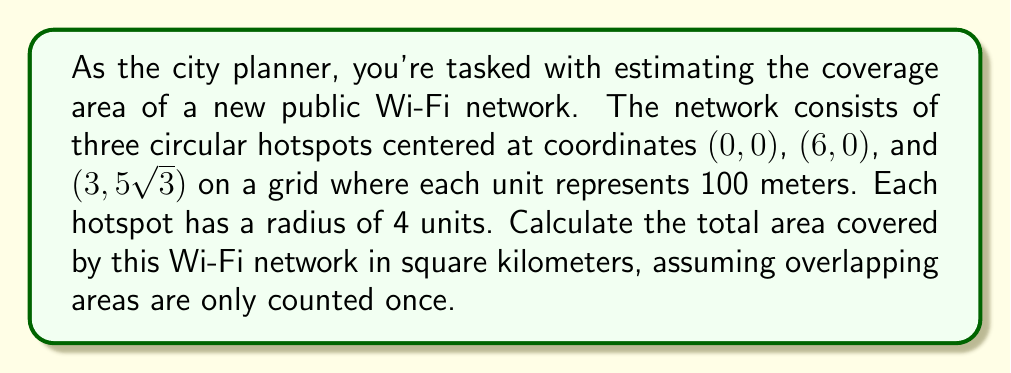Give your solution to this math problem. To solve this problem, we need to follow these steps:

1) First, recognize that the three hotspots form an equilateral triangle. This can be verified by calculating the distances between the centers:

   Distance between (0, 0) and (6, 0): $\sqrt{(6-0)^2 + (0-0)^2} = 6$
   Distance between (6, 0) and (3, 5√3): $\sqrt{(3-6)^2 + (5\sqrt{3}-0)^2} = 6$
   Distance between (3, 5√3) and (0, 0): $\sqrt{(0-3)^2 + (0-5\sqrt{3})^2} = 6$

2) The area of a circle is $\pi r^2$. With a radius of 4 units, each circle has an area of:

   $A = \pi (4)^2 = 16\pi$ square units

3) However, these circles overlap. The area of overlap between two circles can be calculated using the formula:

   $A_{overlap} = 2r^2 \arccos(\frac{d}{2r}) - d\sqrt{r^2 - \frac{d^2}{4}}$

   Where $r$ is the radius (4) and $d$ is the distance between centers (6).

4) Substituting these values:

   $A_{overlap} = 2(4)^2 \arccos(\frac{6}{2(4)}) - 6\sqrt{4^2 - \frac{6^2}{4}}$
                $= 32 \arccos(0.75) - 6\sqrt{16 - 9}$
                $= 32 \arccos(0.75) - 6\sqrt{7}$

5) There are three such overlaps in our configuration.

6) The total area is therefore:

   $A_{total} = 3(16\pi) - 3(32 \arccos(0.75) - 6\sqrt{7})$

7) Simplifying:

   $A_{total} = 48\pi - 96 \arccos(0.75) + 18\sqrt{7}$

8) This is in square units. To convert to square kilometers:

   $A_{km^2} = (48\pi - 96 \arccos(0.75) + 18\sqrt{7}) * (0.1)^2$
              $= 0.48\pi - 0.96 \arccos(0.75) + 0.18\sqrt{7}$
Answer: $0.48\pi - 0.96 \arccos(0.75) + 0.18\sqrt{7} \approx 0.7054$ square kilometers 